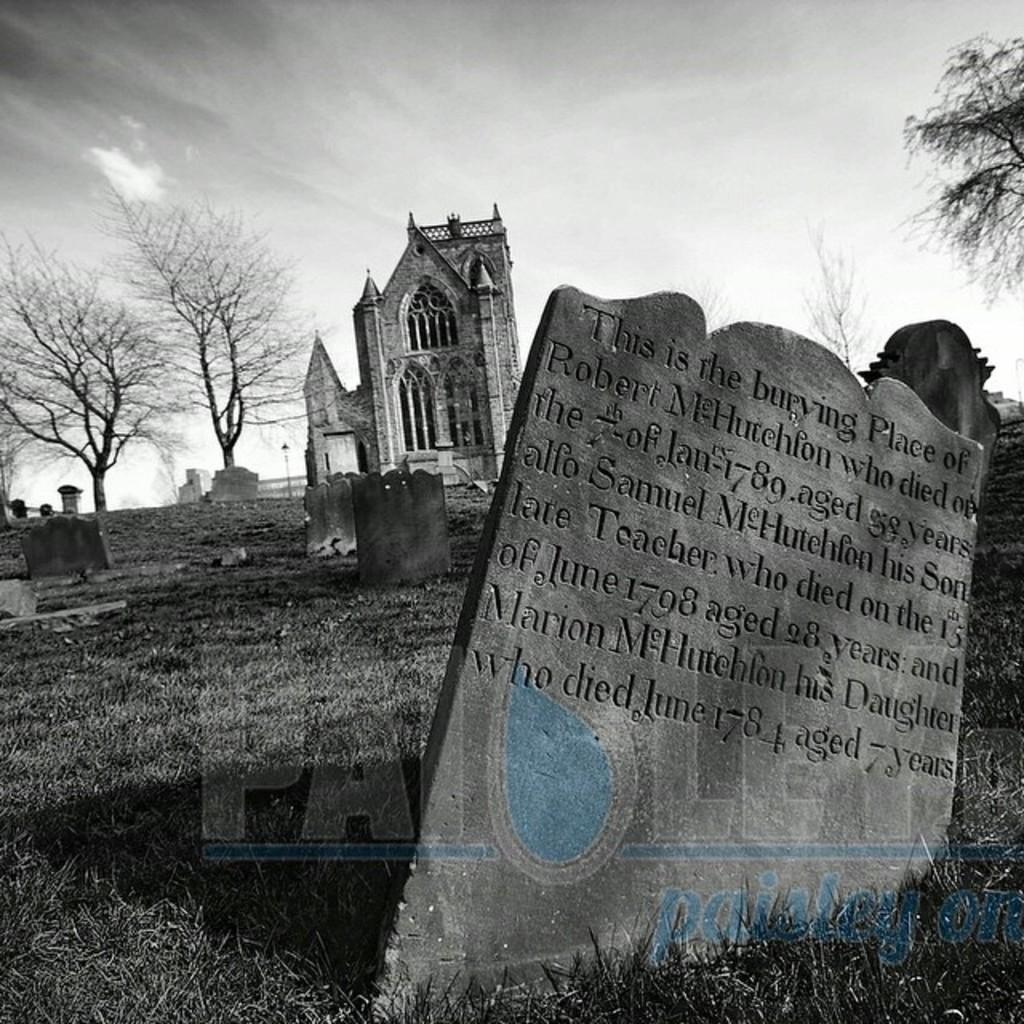Could you give a brief overview of what you see in this image? In this image there is a headstone with some text on it. Behind that there are headstones, trees and a building. There is grass on the surface. At the top of the image there is sky. There is some text at the bottom of the image. 